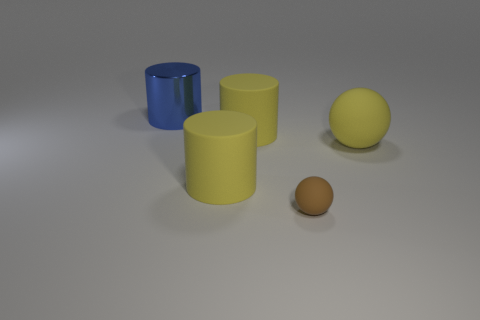Subtract all shiny cylinders. How many cylinders are left? 2 Subtract all yellow balls. How many balls are left? 1 Add 3 small objects. How many objects exist? 8 Subtract all spheres. How many objects are left? 3 Subtract 1 spheres. How many spheres are left? 1 Add 2 large yellow things. How many large yellow things are left? 5 Add 2 big yellow matte cylinders. How many big yellow matte cylinders exist? 4 Subtract 0 blue blocks. How many objects are left? 5 Subtract all purple cylinders. Subtract all green cubes. How many cylinders are left? 3 Subtract all yellow spheres. How many blue cylinders are left? 1 